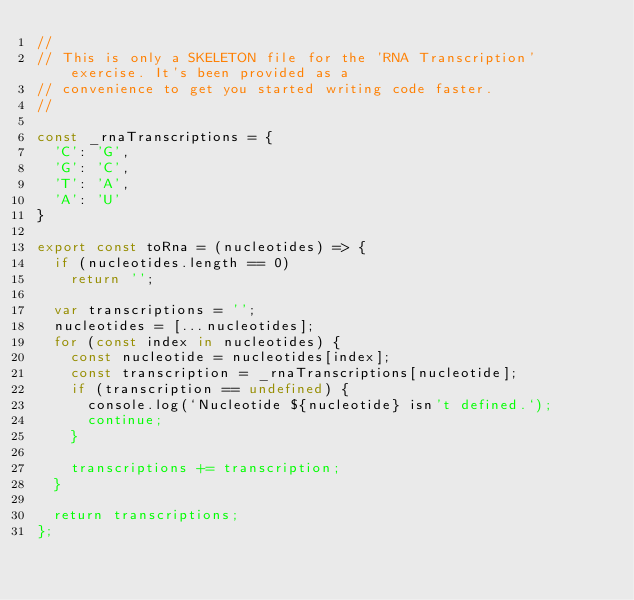Convert code to text. <code><loc_0><loc_0><loc_500><loc_500><_JavaScript_>//
// This is only a SKELETON file for the 'RNA Transcription' exercise. It's been provided as a
// convenience to get you started writing code faster.
//

const _rnaTranscriptions = {
  'C': 'G',
  'G': 'C',
  'T': 'A',
  'A': 'U'
}

export const toRna = (nucleotides) => {
  if (nucleotides.length == 0)
    return '';

  var transcriptions = '';
  nucleotides = [...nucleotides];
  for (const index in nucleotides) {
    const nucleotide = nucleotides[index];
    const transcription = _rnaTranscriptions[nucleotide];
    if (transcription == undefined) {
      console.log(`Nucleotide ${nucleotide} isn't defined.`);
      continue;
    }

    transcriptions += transcription;
  }

  return transcriptions;
};
</code> 